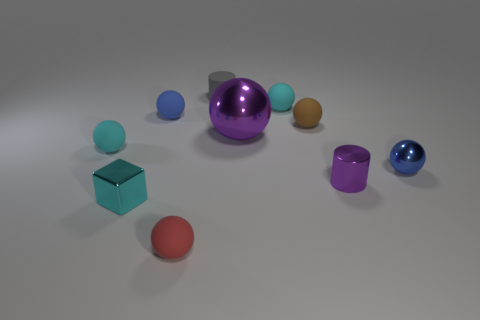How many other things are there of the same shape as the big thing?
Make the answer very short. 6. There is a small rubber thing that is behind the cyan matte object that is on the right side of the cyan matte ball that is left of the gray matte object; what is its shape?
Provide a short and direct response. Cylinder. There is a purple shiny object that is the same shape as the tiny gray matte thing; what size is it?
Offer a very short reply. Small. How big is the object that is right of the small block and in front of the tiny purple object?
Your response must be concise. Small. What shape is the small object that is the same color as the large sphere?
Offer a terse response. Cylinder. What color is the shiny cylinder?
Your answer should be very brief. Purple. What is the size of the cyan matte sphere in front of the small brown ball?
Your response must be concise. Small. There is a small cylinder that is in front of the cyan sphere that is behind the brown rubber ball; how many blue metallic objects are behind it?
Your answer should be compact. 1. There is a matte thing that is left of the blue sphere that is behind the brown ball; what is its color?
Provide a short and direct response. Cyan. Are there any blocks of the same size as the purple metal ball?
Make the answer very short. No. 